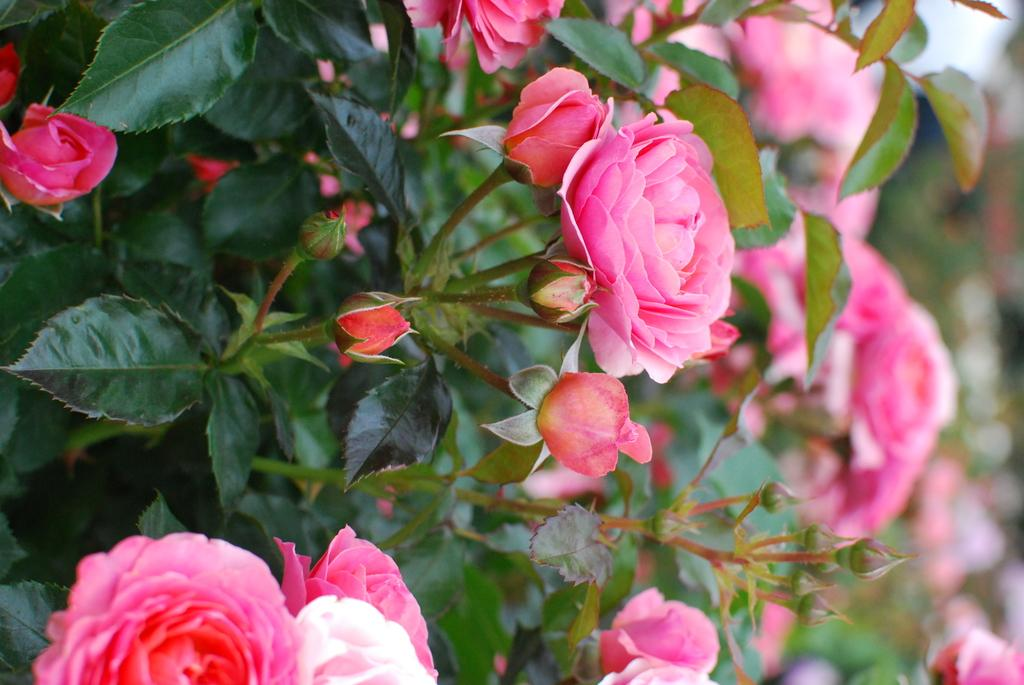What type of plant life is present in the image? There are flowers in the image. Can you describe the structure of the flowers? The flowers have stems and leaves. What type of rod can be seen in the image? There is no rod present in the image. What does the dad in the image say about the flowers? There is no dad or any dialogue present in the image. 